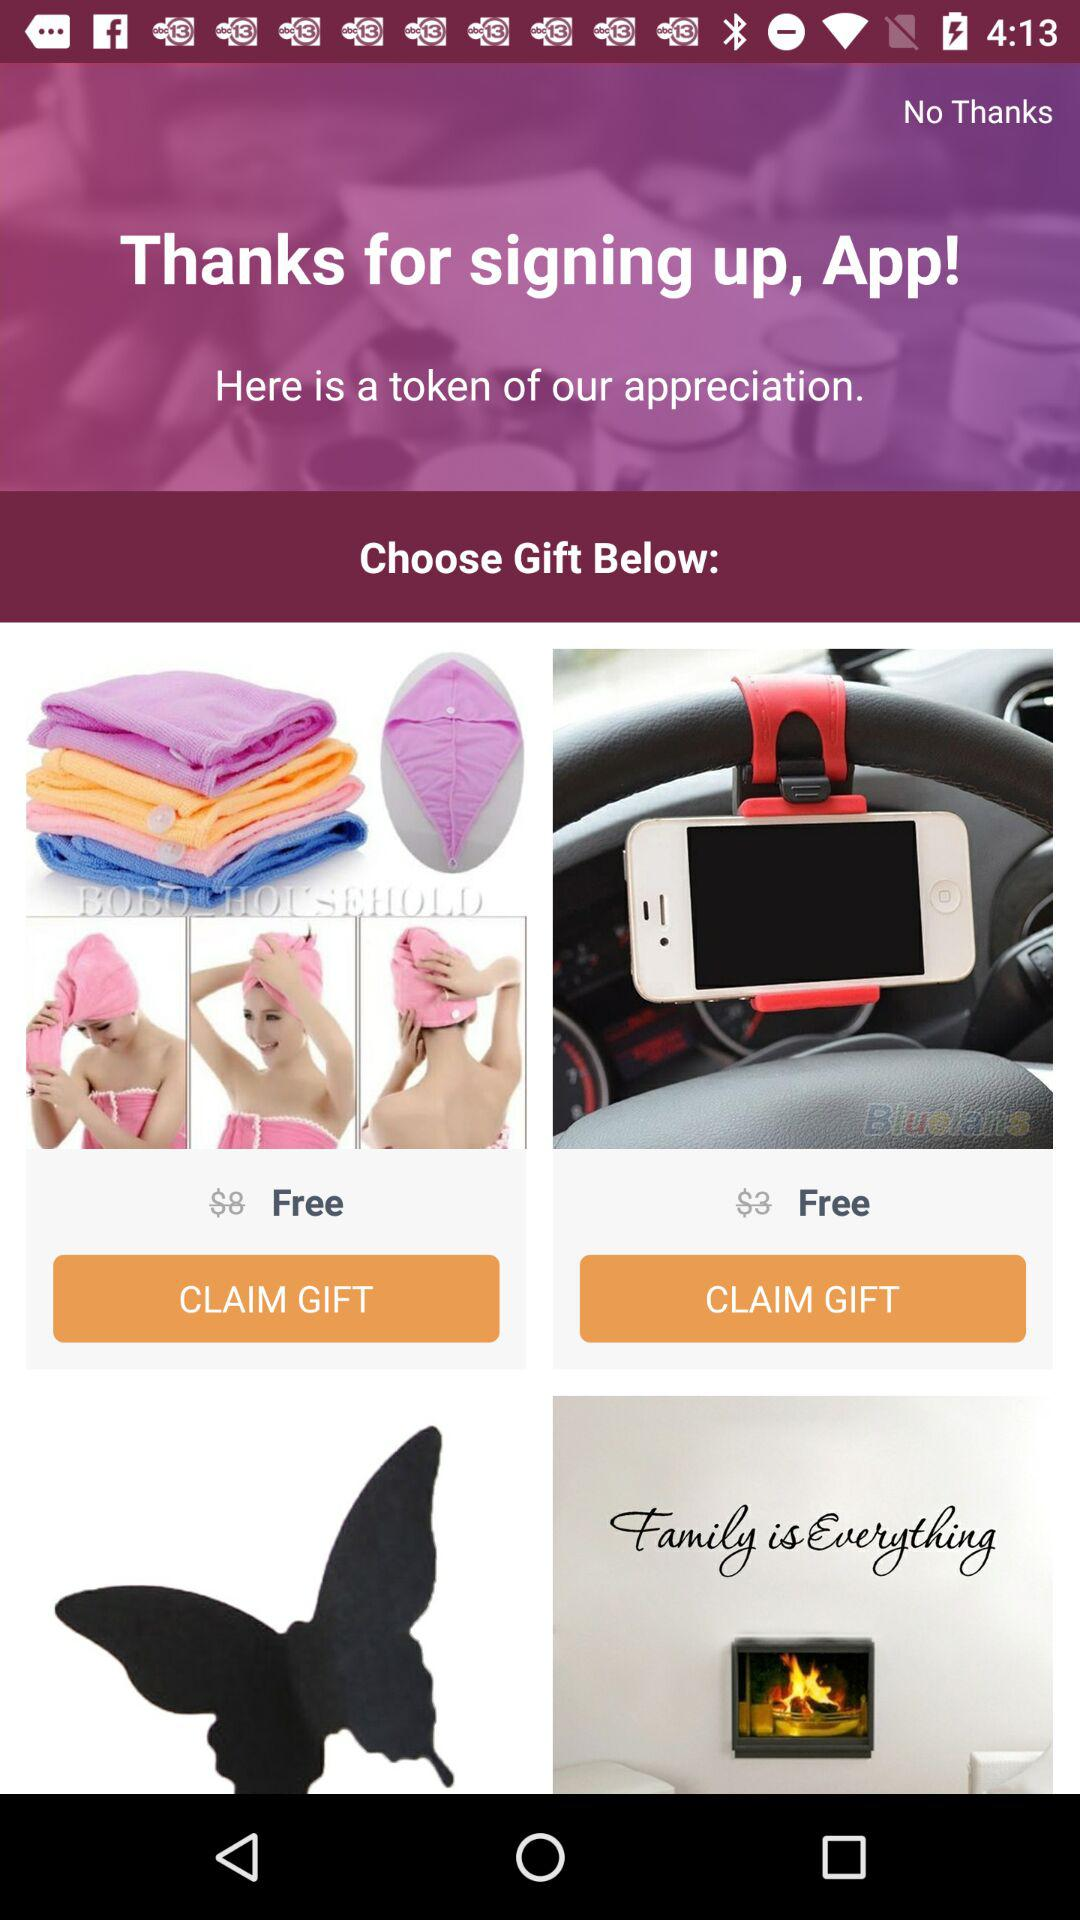How many of the gifts are free?
Answer the question using a single word or phrase. 2 